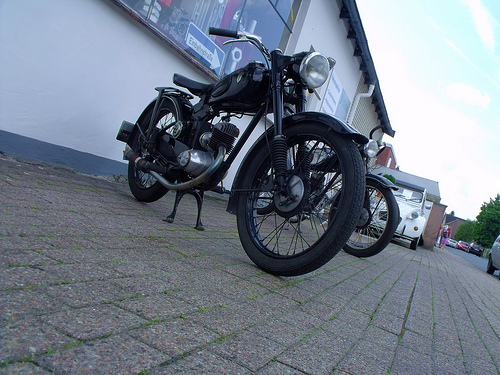<image>
Can you confirm if the bike is to the left of the car? No. The bike is not to the left of the car. From this viewpoint, they have a different horizontal relationship. Is the motorcycle behind the car? No. The motorcycle is not behind the car. From this viewpoint, the motorcycle appears to be positioned elsewhere in the scene. Is the floor in front of the bike? No. The floor is not in front of the bike. The spatial positioning shows a different relationship between these objects. 